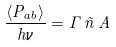Convert formula to latex. <formula><loc_0><loc_0><loc_500><loc_500>\frac { \langle P _ { a b } \rangle } { h \nu } = \Gamma \, \tilde { n } \, A</formula> 